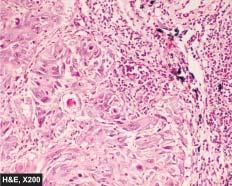how are a few well-developed cell nests with keratinisation?
Answer the question using a single word or phrase. Evident 